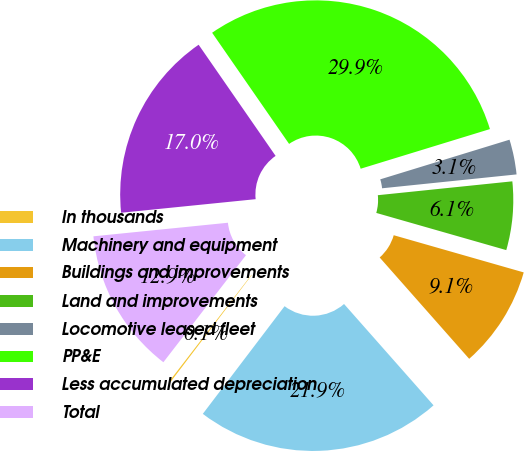<chart> <loc_0><loc_0><loc_500><loc_500><pie_chart><fcel>In thousands<fcel>Machinery and equipment<fcel>Buildings and improvements<fcel>Land and improvements<fcel>Locomotive leased fleet<fcel>PP&E<fcel>Less accumulated depreciation<fcel>Total<nl><fcel>0.12%<fcel>21.85%<fcel>9.05%<fcel>6.07%<fcel>3.1%<fcel>29.9%<fcel>16.96%<fcel>12.94%<nl></chart> 